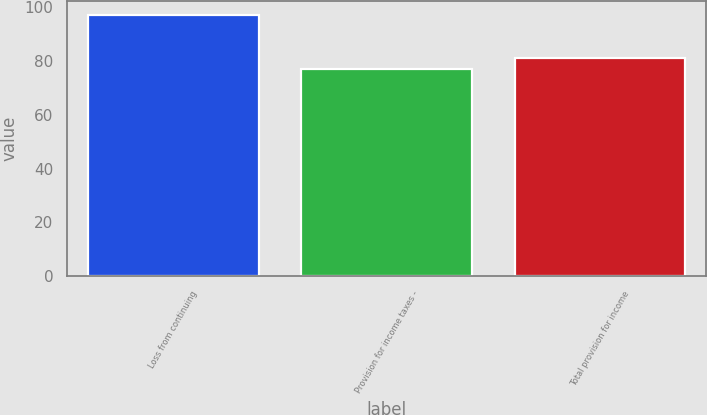Convert chart. <chart><loc_0><loc_0><loc_500><loc_500><bar_chart><fcel>Loss from continuing<fcel>Provision for income taxes -<fcel>Total provision for income<nl><fcel>97.3<fcel>77.2<fcel>81.2<nl></chart> 